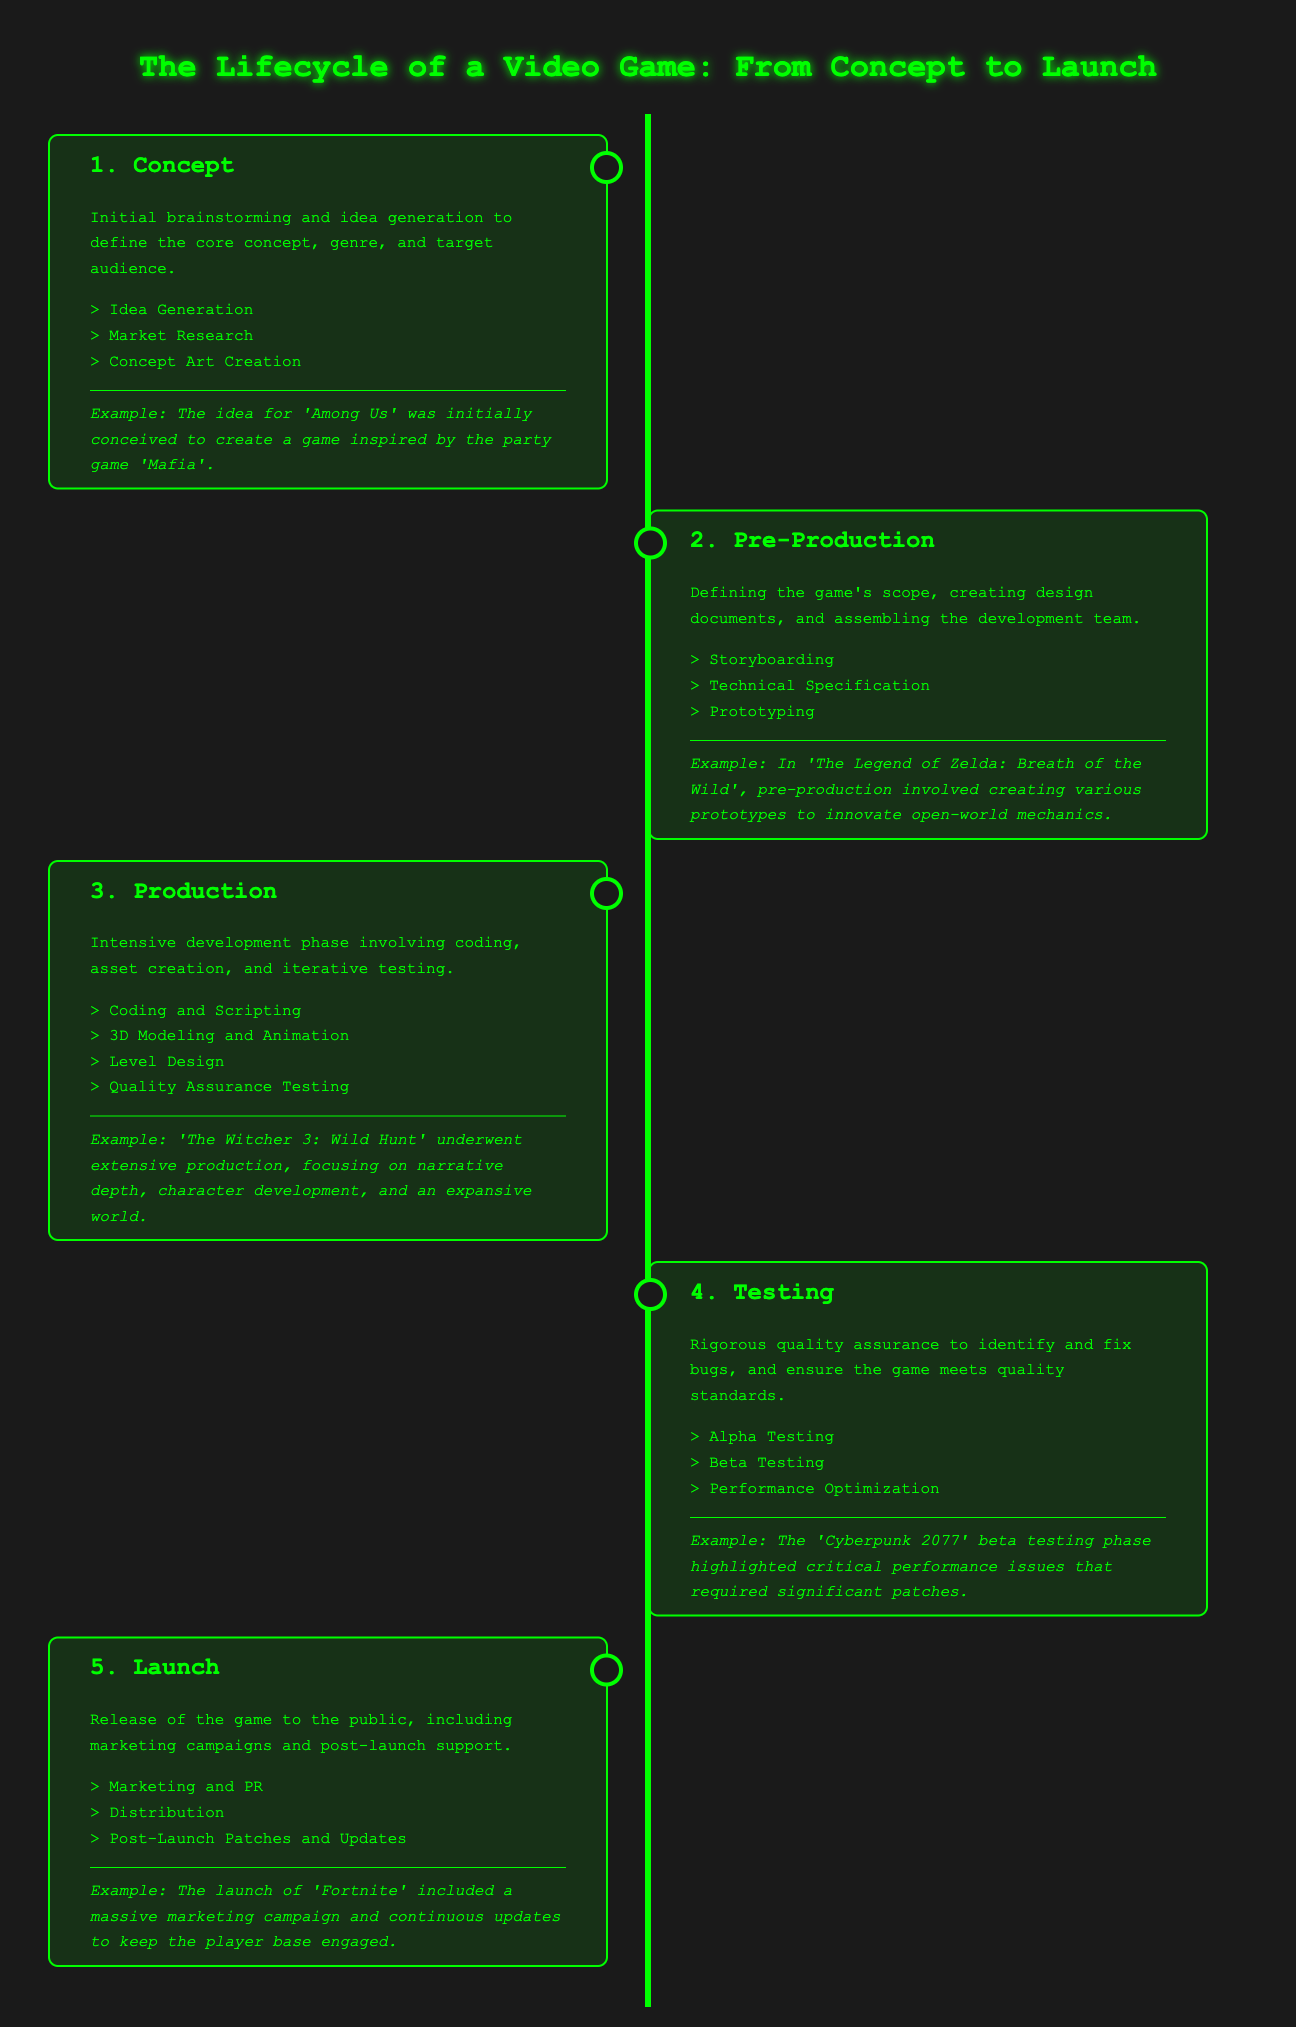What is the first phase of the video game lifecycle? The first phase is titled "Concept" and involves initial brainstorming and idea generation.
Answer: Concept Which phase involves rigorous quality assurance? The phase focusing on quality assurance is described as "Testing."
Answer: Testing What is an example game from the Concept phase? The document notes that 'Among Us' was conceived during the Concept phase.
Answer: Among Us In which phase is prototyping done? Prototyping is part of the second phase, "Pre-Production."
Answer: Pre-Production How many phases are included in the video game lifecycle? The document outlines a total of five distinct phases in the lifecycle.
Answer: Five What significant issue was highlighted during the Testing phase of 'Cyberpunk 2077'? The Testing phase highlighted critical performance issues that required significant patches.
Answer: Performance issues Which phase emphasizes marketing campaigns and post-launch support? The last phase, "Launch," focuses on marketing campaigns and post-launch support.
Answer: Launch What type of testing occurs before the game is fully launched? The phases that occur before launch and involve testing are "Alpha Testing" and "Beta Testing."
Answer: Alpha Testing and Beta Testing 